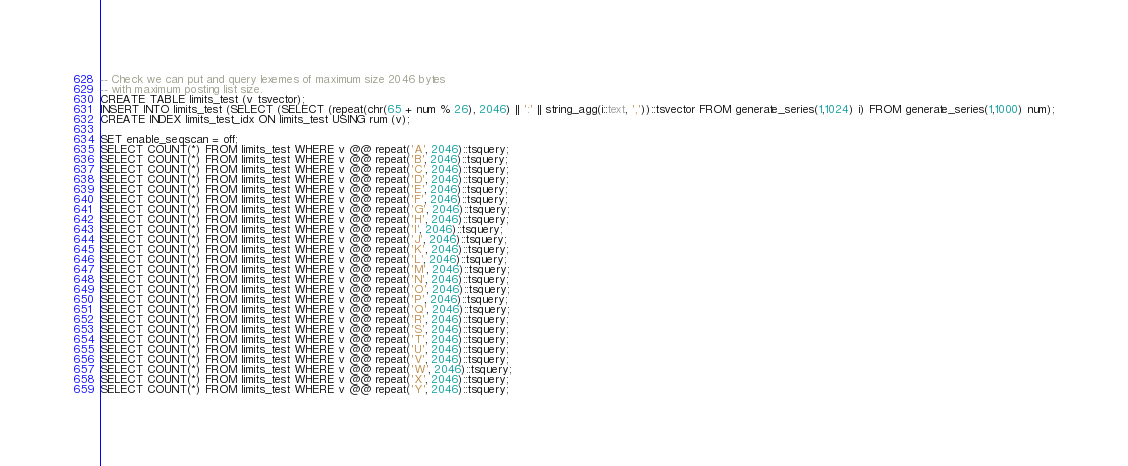Convert code to text. <code><loc_0><loc_0><loc_500><loc_500><_SQL_>-- Check we can put and query lexemes of maximum size 2046 bytes
-- with maximum posting list size.
CREATE TABLE limits_test (v tsvector);
INSERT INTO limits_test (SELECT (SELECT (repeat(chr(65 + num % 26), 2046) || ':' || string_agg(i::text, ','))::tsvector FROM generate_series(1,1024) i) FROM generate_series(1,1000) num);
CREATE INDEX limits_test_idx ON limits_test USING rum (v);

SET enable_seqscan = off;
SELECT COUNT(*) FROM limits_test WHERE v @@ repeat('A', 2046)::tsquery;
SELECT COUNT(*) FROM limits_test WHERE v @@ repeat('B', 2046)::tsquery;
SELECT COUNT(*) FROM limits_test WHERE v @@ repeat('C', 2046)::tsquery;
SELECT COUNT(*) FROM limits_test WHERE v @@ repeat('D', 2046)::tsquery;
SELECT COUNT(*) FROM limits_test WHERE v @@ repeat('E', 2046)::tsquery;
SELECT COUNT(*) FROM limits_test WHERE v @@ repeat('F', 2046)::tsquery;
SELECT COUNT(*) FROM limits_test WHERE v @@ repeat('G', 2046)::tsquery;
SELECT COUNT(*) FROM limits_test WHERE v @@ repeat('H', 2046)::tsquery;
SELECT COUNT(*) FROM limits_test WHERE v @@ repeat('I', 2046)::tsquery;
SELECT COUNT(*) FROM limits_test WHERE v @@ repeat('J', 2046)::tsquery;
SELECT COUNT(*) FROM limits_test WHERE v @@ repeat('K', 2046)::tsquery;
SELECT COUNT(*) FROM limits_test WHERE v @@ repeat('L', 2046)::tsquery;
SELECT COUNT(*) FROM limits_test WHERE v @@ repeat('M', 2046)::tsquery;
SELECT COUNT(*) FROM limits_test WHERE v @@ repeat('N', 2046)::tsquery;
SELECT COUNT(*) FROM limits_test WHERE v @@ repeat('O', 2046)::tsquery;
SELECT COUNT(*) FROM limits_test WHERE v @@ repeat('P', 2046)::tsquery;
SELECT COUNT(*) FROM limits_test WHERE v @@ repeat('Q', 2046)::tsquery;
SELECT COUNT(*) FROM limits_test WHERE v @@ repeat('R', 2046)::tsquery;
SELECT COUNT(*) FROM limits_test WHERE v @@ repeat('S', 2046)::tsquery;
SELECT COUNT(*) FROM limits_test WHERE v @@ repeat('T', 2046)::tsquery;
SELECT COUNT(*) FROM limits_test WHERE v @@ repeat('U', 2046)::tsquery;
SELECT COUNT(*) FROM limits_test WHERE v @@ repeat('V', 2046)::tsquery;
SELECT COUNT(*) FROM limits_test WHERE v @@ repeat('W', 2046)::tsquery;
SELECT COUNT(*) FROM limits_test WHERE v @@ repeat('X', 2046)::tsquery;
SELECT COUNT(*) FROM limits_test WHERE v @@ repeat('Y', 2046)::tsquery;</code> 